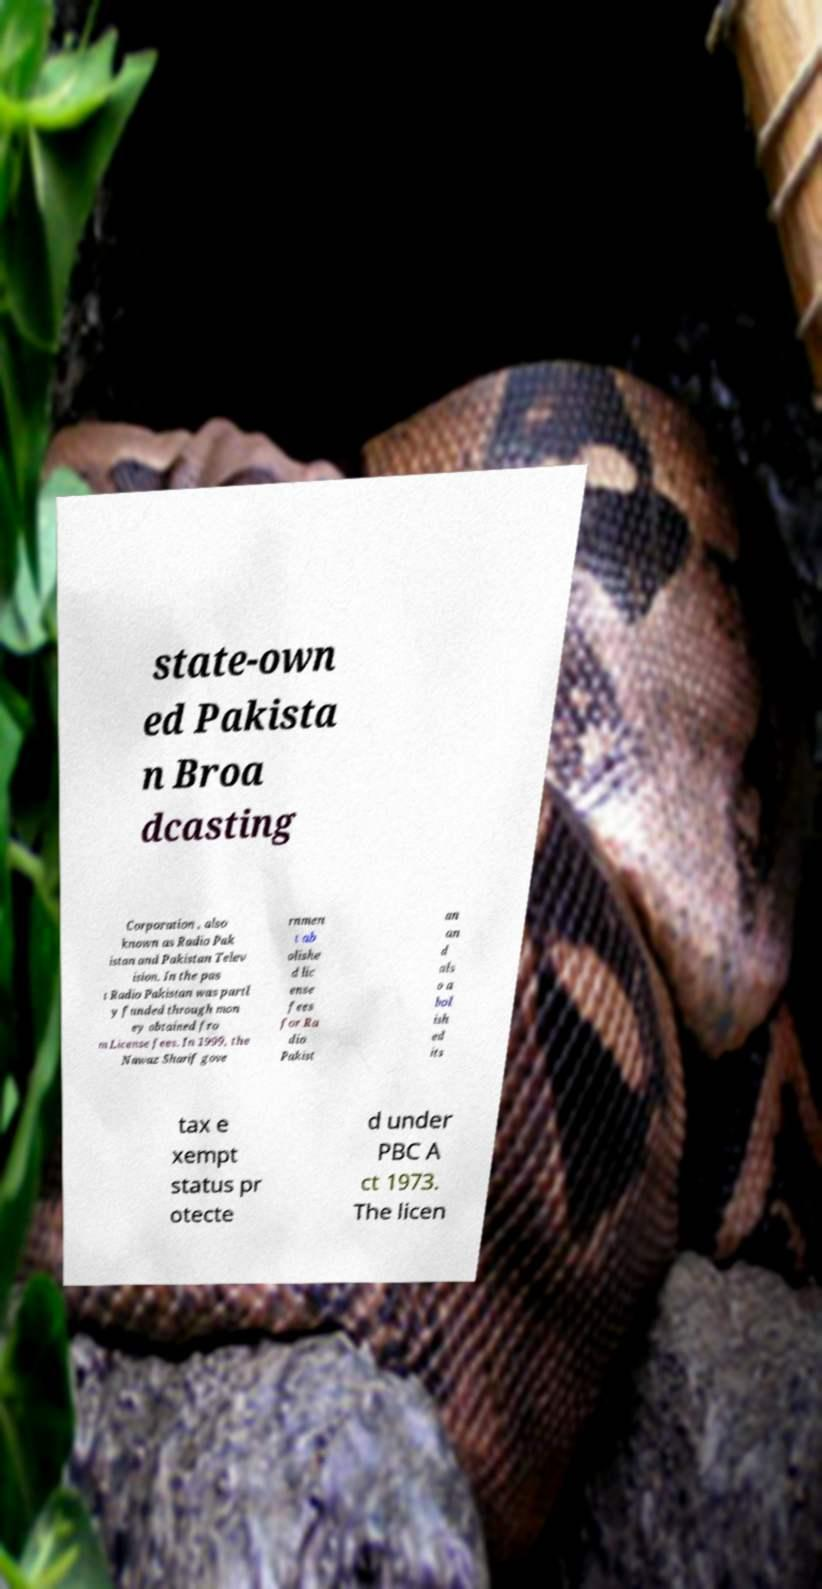Please read and relay the text visible in this image. What does it say? state-own ed Pakista n Broa dcasting Corporation , also known as Radio Pak istan and Pakistan Telev ision. In the pas t Radio Pakistan was partl y funded through mon ey obtained fro m License fees. In 1999, the Nawaz Sharif gove rnmen t ab olishe d lic ense fees for Ra dio Pakist an an d als o a bol ish ed its tax e xempt status pr otecte d under PBC A ct 1973. The licen 